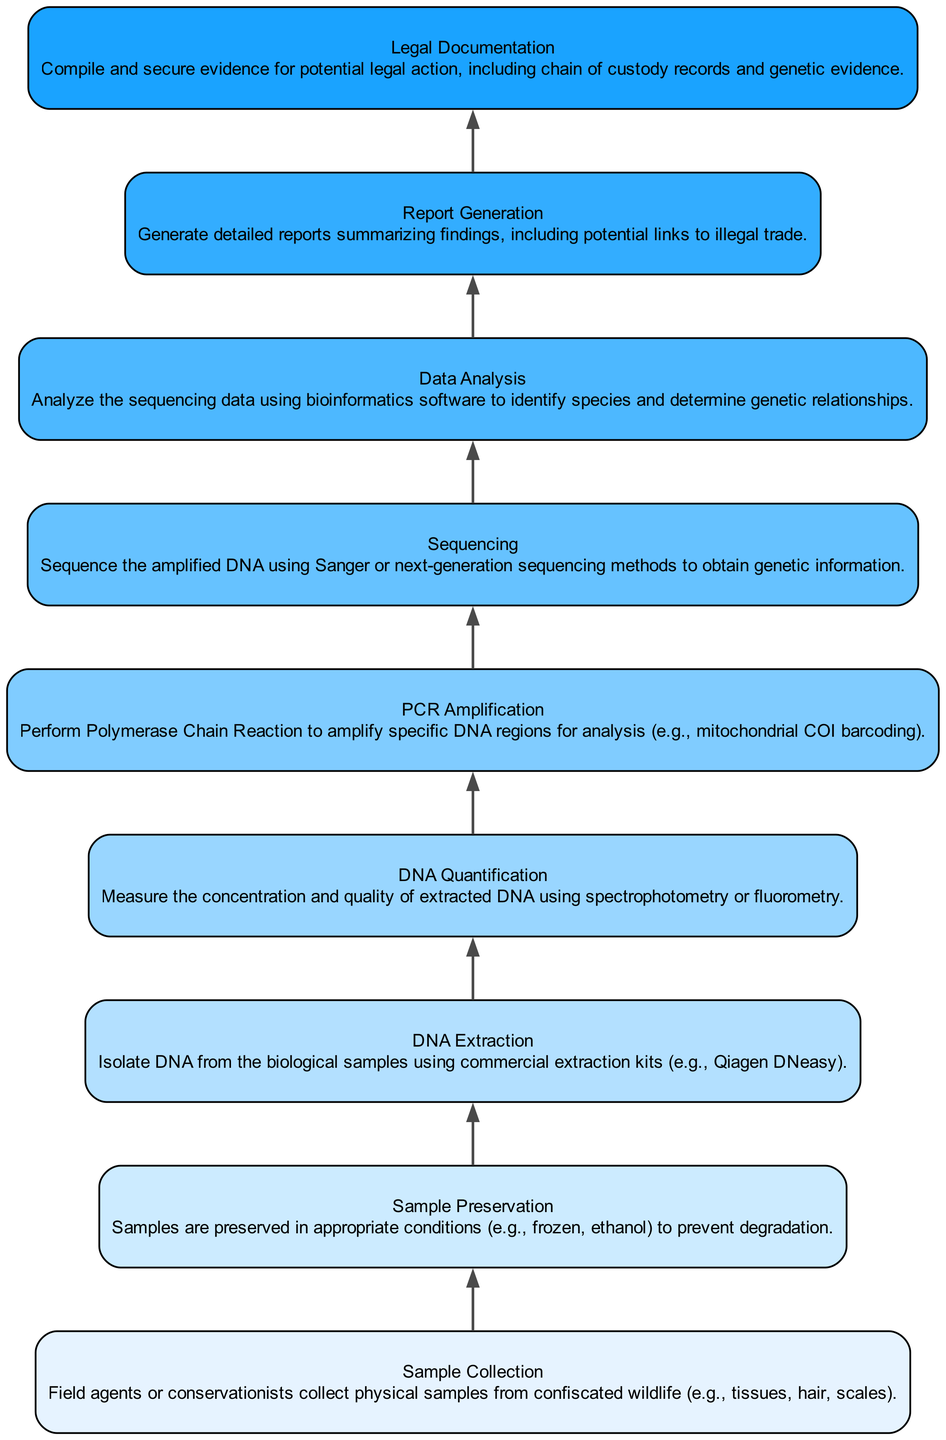What is the first step in the laboratory process? The diagram starts with "Sample Collection," indicating that's the first step in the laboratory process.
Answer: Sample Collection How many steps are there in total? By counting all the elements in the diagram, there are nine distinct steps from "Sample Collection" to "Legal Documentation."
Answer: Nine Which step comes after DNA Quantification? The diagram shows that "PCR Amplification" follows "DNA Quantification," indicating the subsequent step.
Answer: PCR Amplification What type of samples are collected? The description under "Sample Collection" specifies that physical samples such as tissues, hair, and scales are collected.
Answer: Tissues, hair, scales What is done after Sequencing? According to the flow, "Data Analysis" is the next step that follows "Sequencing," which involves analyzing the sequenced DNA.
Answer: Data Analysis Which step is focused on legal action? The final step in the flow, "Legal Documentation," is dedicated to compiling and securing evidence for potential legal actions.
Answer: Legal Documentation What method is used for DNA extraction? In the "DNA Extraction" step, it mentions using commercial extraction kits, specifically referencing Qiagen DNeasy.
Answer: Qiagen DNeasy How are samples preserved? The step "Sample Preservation" describes that samples are preserved in conditions such as frozen or ethanol to prevent degradation.
Answer: Frozen, ethanol What is the primary goal of the Report Generation step? The "Report Generation" section indicates that the goal is to summarize findings and include links to illegal trade, highlighting its investigative nature.
Answer: Summarizing findings 